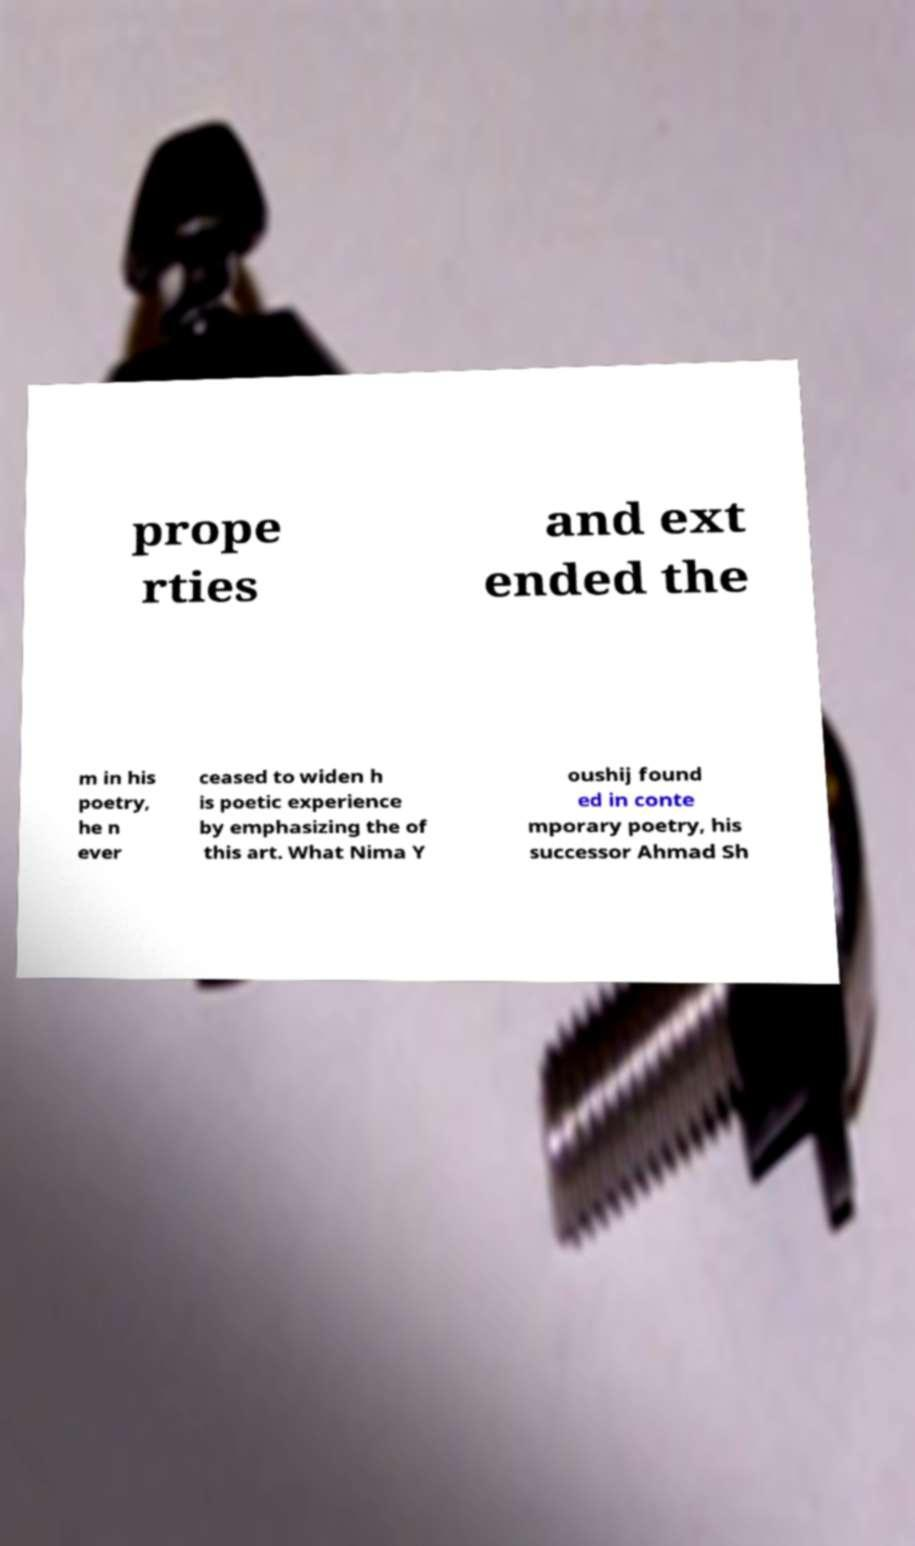I need the written content from this picture converted into text. Can you do that? prope rties and ext ended the m in his poetry, he n ever ceased to widen h is poetic experience by emphasizing the of this art. What Nima Y oushij found ed in conte mporary poetry, his successor Ahmad Sh 